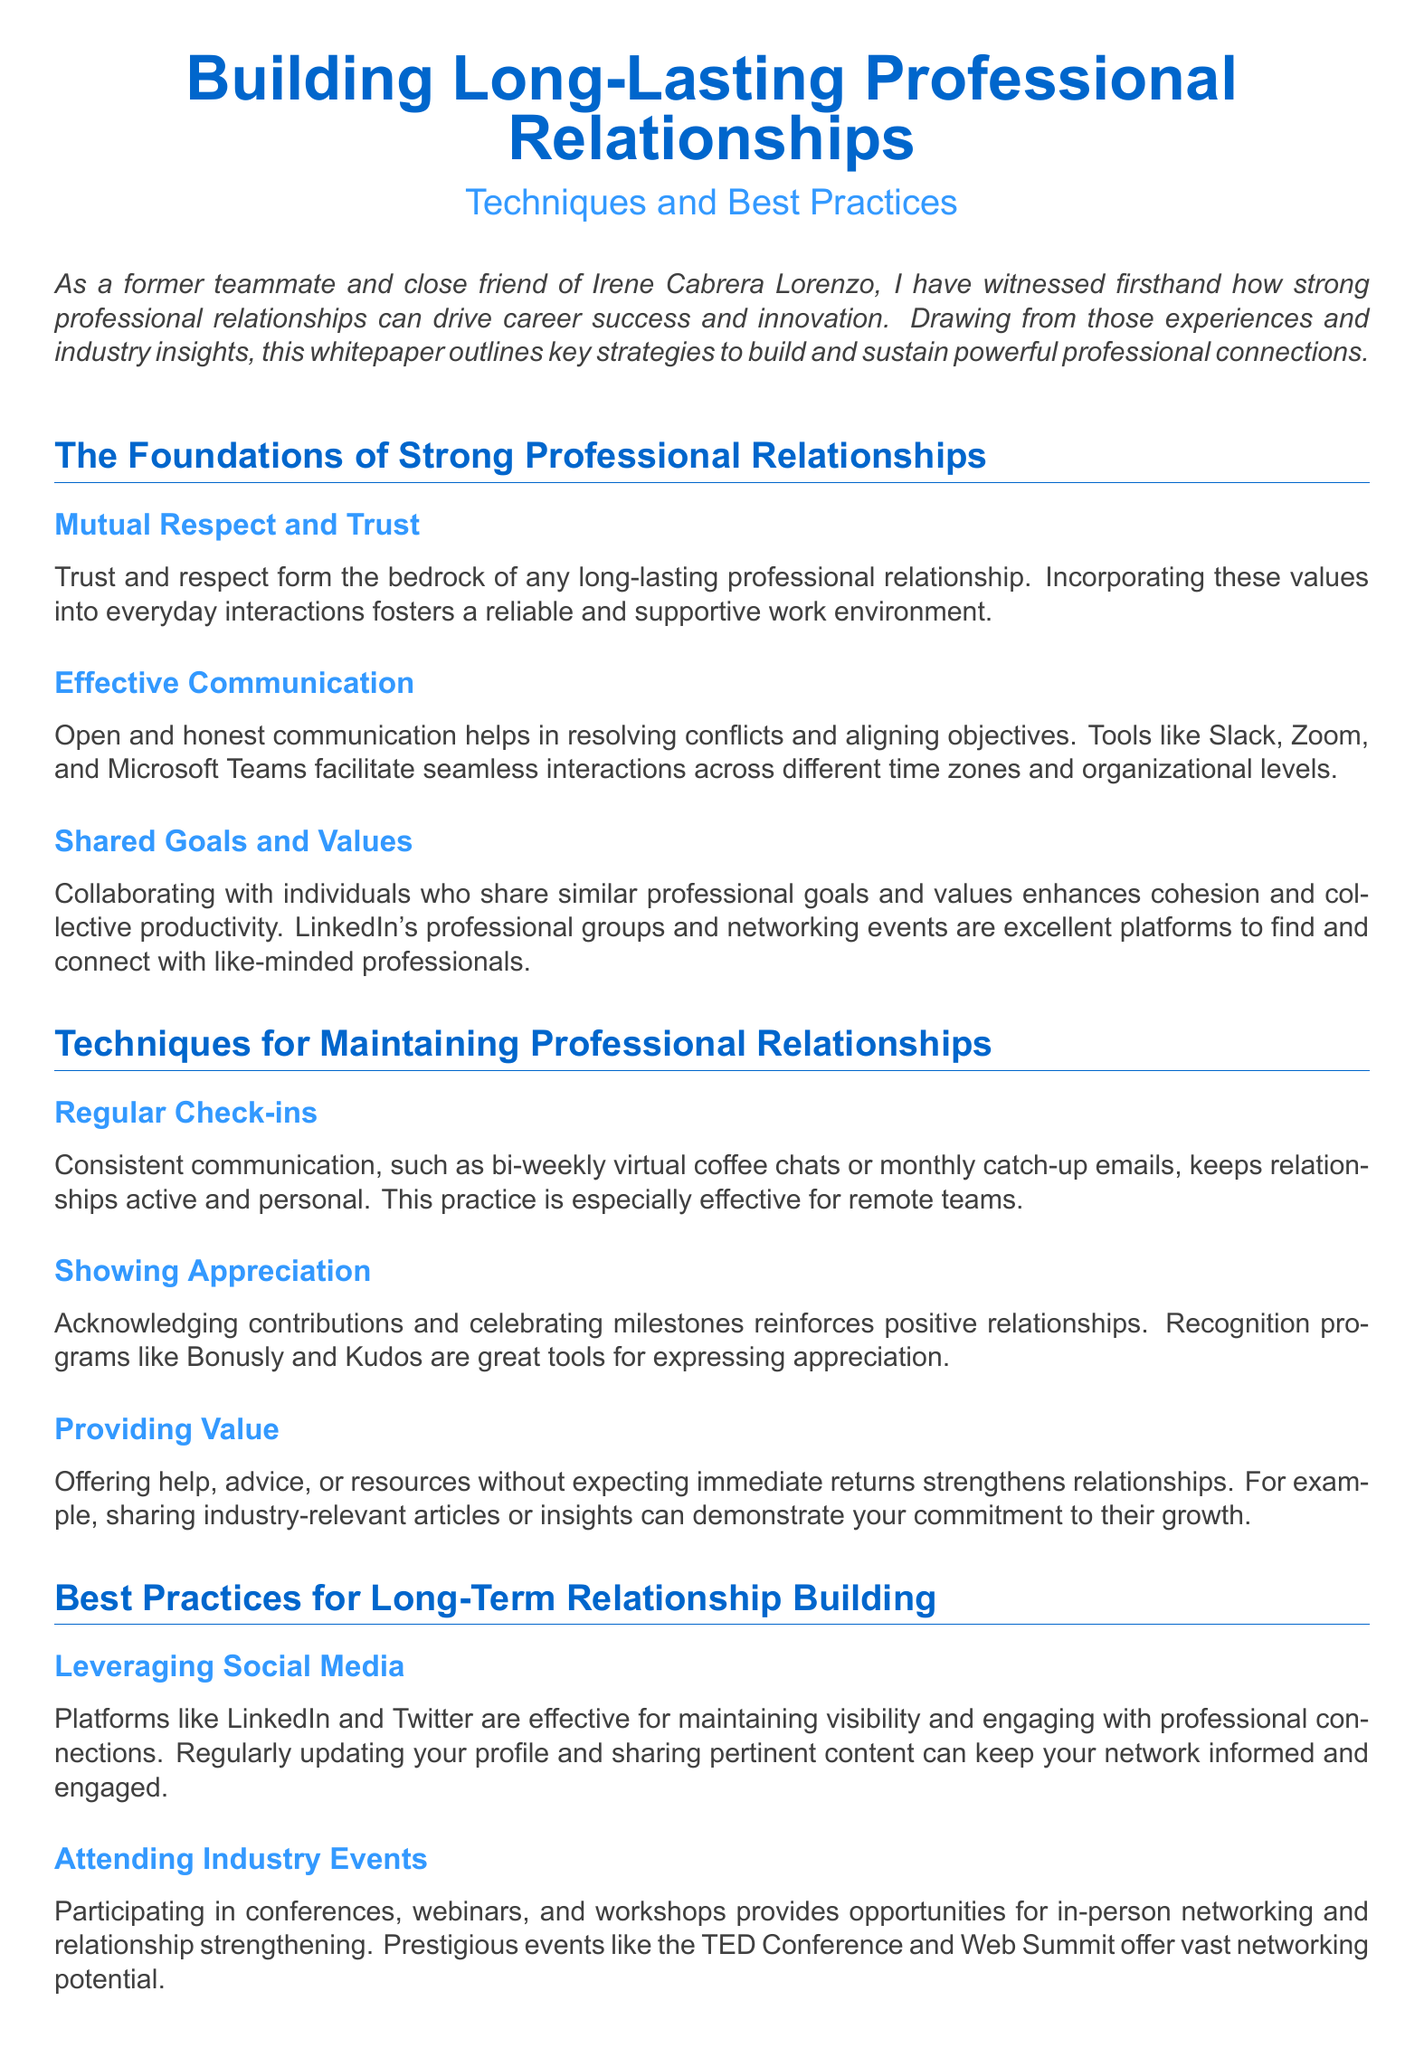What is the title of the whitepaper? The title of the whitepaper is stated prominently at the top of the document.
Answer: Building Long-Lasting Professional Relationships What color is the main heading? The color assigned to the main heading is specified in the color definitions within the document.
Answer: RGB(0,102,204) What is one tool mentioned for effective communication? The document lists specific tools that facilitate communication.
Answer: Slack How often should regular check-ins occur? The document suggests a frequency for maintaining communication in relationships.
Answer: bi-weekly What is a way to show appreciation mentioned in the document? One of the techniques listed for maintaining relationships highlights specific methods of expressing gratitude.
Answer: Recognition programs Name one platform for maintaining visibility mentioned. The document refers to specific social media platforms useful for networking.
Answer: LinkedIn What type of events are suggested for in-person networking? The document lists a category of events beneficial for strengthening professional connections.
Answer: Industry events What does mentorship help build? The document emphasizes the relationship aspects fostered through mentorship.
Answer: Reciprocal relationships What is emphasized as a foundation for strong professional relationships? The document outlines key foundational values necessary for lasting relationships.
Answer: Trust and respect 